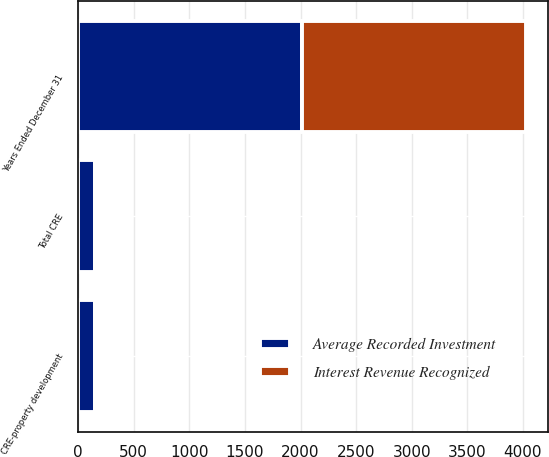<chart> <loc_0><loc_0><loc_500><loc_500><stacked_bar_chart><ecel><fcel>Years Ended December 31<fcel>CRE-property development<fcel>Total CRE<nl><fcel>Average Recorded Investment<fcel>2013<fcel>148<fcel>148<nl><fcel>Interest Revenue Recognized<fcel>2013<fcel>19<fcel>19<nl></chart> 